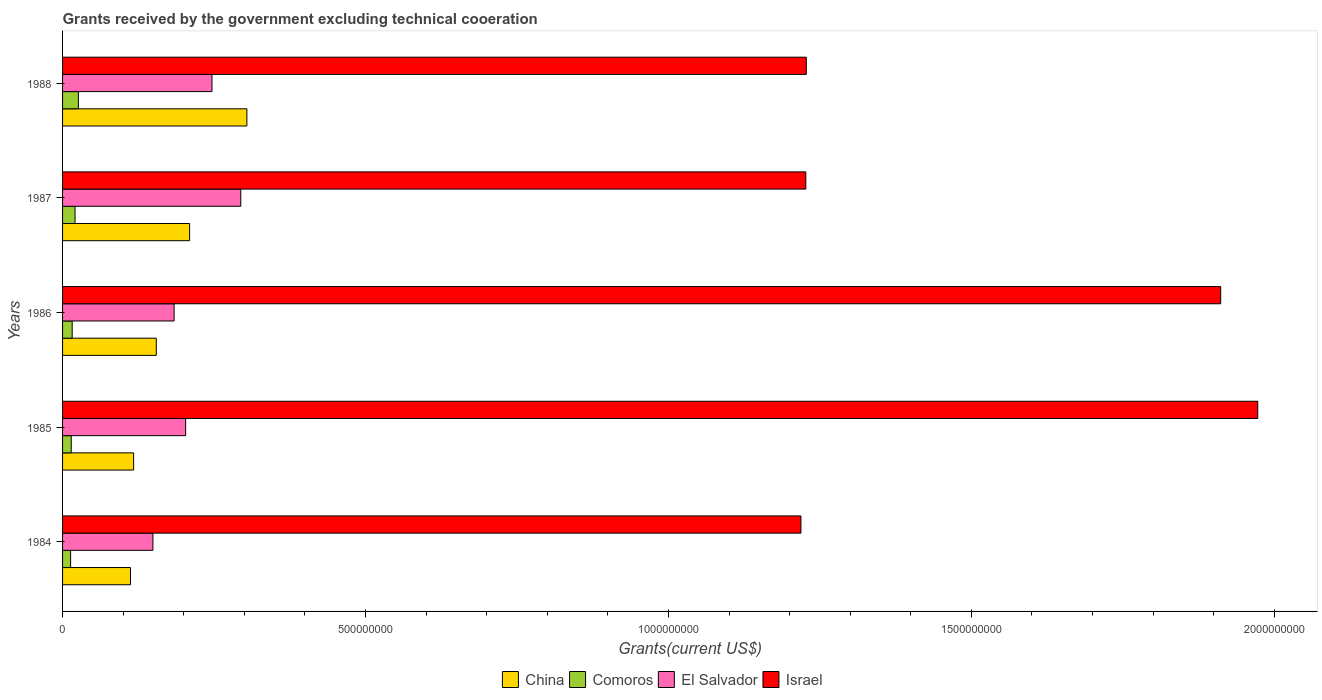How many different coloured bars are there?
Give a very brief answer. 4. Are the number of bars per tick equal to the number of legend labels?
Provide a short and direct response. Yes. How many bars are there on the 3rd tick from the bottom?
Provide a succinct answer. 4. What is the label of the 4th group of bars from the top?
Make the answer very short. 1985. In how many cases, is the number of bars for a given year not equal to the number of legend labels?
Your answer should be very brief. 0. What is the total grants received by the government in Israel in 1984?
Your response must be concise. 1.22e+09. Across all years, what is the maximum total grants received by the government in Israel?
Your answer should be very brief. 1.97e+09. Across all years, what is the minimum total grants received by the government in Israel?
Offer a terse response. 1.22e+09. In which year was the total grants received by the government in China maximum?
Offer a very short reply. 1988. What is the total total grants received by the government in Comoros in the graph?
Offer a very short reply. 9.02e+07. What is the difference between the total grants received by the government in China in 1985 and that in 1987?
Ensure brevity in your answer.  -9.24e+07. What is the difference between the total grants received by the government in Comoros in 1986 and the total grants received by the government in Israel in 1984?
Provide a short and direct response. -1.20e+09. What is the average total grants received by the government in Israel per year?
Your response must be concise. 1.51e+09. In the year 1987, what is the difference between the total grants received by the government in Comoros and total grants received by the government in Israel?
Provide a succinct answer. -1.21e+09. What is the ratio of the total grants received by the government in Comoros in 1984 to that in 1988?
Your answer should be compact. 0.51. Is the total grants received by the government in El Salvador in 1986 less than that in 1987?
Offer a terse response. Yes. What is the difference between the highest and the second highest total grants received by the government in China?
Ensure brevity in your answer.  9.45e+07. What is the difference between the highest and the lowest total grants received by the government in El Salvador?
Your answer should be compact. 1.45e+08. In how many years, is the total grants received by the government in Comoros greater than the average total grants received by the government in Comoros taken over all years?
Your answer should be very brief. 2. Is it the case that in every year, the sum of the total grants received by the government in Comoros and total grants received by the government in El Salvador is greater than the sum of total grants received by the government in China and total grants received by the government in Israel?
Give a very brief answer. No. What does the 2nd bar from the top in 1984 represents?
Make the answer very short. El Salvador. What does the 4th bar from the bottom in 1987 represents?
Provide a short and direct response. Israel. Is it the case that in every year, the sum of the total grants received by the government in El Salvador and total grants received by the government in Israel is greater than the total grants received by the government in China?
Make the answer very short. Yes. How many bars are there?
Provide a succinct answer. 20. Are all the bars in the graph horizontal?
Provide a succinct answer. Yes. What is the difference between two consecutive major ticks on the X-axis?
Offer a very short reply. 5.00e+08. Are the values on the major ticks of X-axis written in scientific E-notation?
Offer a very short reply. No. Does the graph contain any zero values?
Offer a very short reply. No. Where does the legend appear in the graph?
Offer a very short reply. Bottom center. What is the title of the graph?
Make the answer very short. Grants received by the government excluding technical cooeration. What is the label or title of the X-axis?
Your answer should be compact. Grants(current US$). What is the Grants(current US$) in China in 1984?
Ensure brevity in your answer.  1.12e+08. What is the Grants(current US$) in Comoros in 1984?
Keep it short and to the point. 1.33e+07. What is the Grants(current US$) in El Salvador in 1984?
Your answer should be very brief. 1.49e+08. What is the Grants(current US$) in Israel in 1984?
Make the answer very short. 1.22e+09. What is the Grants(current US$) of China in 1985?
Make the answer very short. 1.17e+08. What is the Grants(current US$) of Comoros in 1985?
Ensure brevity in your answer.  1.43e+07. What is the Grants(current US$) in El Salvador in 1985?
Make the answer very short. 2.03e+08. What is the Grants(current US$) in Israel in 1985?
Your answer should be compact. 1.97e+09. What is the Grants(current US$) of China in 1986?
Offer a terse response. 1.55e+08. What is the Grants(current US$) of Comoros in 1986?
Offer a very short reply. 1.59e+07. What is the Grants(current US$) in El Salvador in 1986?
Offer a very short reply. 1.84e+08. What is the Grants(current US$) in Israel in 1986?
Your answer should be very brief. 1.91e+09. What is the Grants(current US$) in China in 1987?
Ensure brevity in your answer.  2.10e+08. What is the Grants(current US$) in Comoros in 1987?
Ensure brevity in your answer.  2.06e+07. What is the Grants(current US$) in El Salvador in 1987?
Provide a short and direct response. 2.94e+08. What is the Grants(current US$) in Israel in 1987?
Offer a terse response. 1.23e+09. What is the Grants(current US$) of China in 1988?
Your answer should be very brief. 3.04e+08. What is the Grants(current US$) of Comoros in 1988?
Your response must be concise. 2.61e+07. What is the Grants(current US$) in El Salvador in 1988?
Give a very brief answer. 2.47e+08. What is the Grants(current US$) in Israel in 1988?
Ensure brevity in your answer.  1.23e+09. Across all years, what is the maximum Grants(current US$) in China?
Make the answer very short. 3.04e+08. Across all years, what is the maximum Grants(current US$) of Comoros?
Ensure brevity in your answer.  2.61e+07. Across all years, what is the maximum Grants(current US$) of El Salvador?
Your answer should be very brief. 2.94e+08. Across all years, what is the maximum Grants(current US$) of Israel?
Make the answer very short. 1.97e+09. Across all years, what is the minimum Grants(current US$) in China?
Your answer should be compact. 1.12e+08. Across all years, what is the minimum Grants(current US$) of Comoros?
Ensure brevity in your answer.  1.33e+07. Across all years, what is the minimum Grants(current US$) in El Salvador?
Offer a terse response. 1.49e+08. Across all years, what is the minimum Grants(current US$) of Israel?
Keep it short and to the point. 1.22e+09. What is the total Grants(current US$) of China in the graph?
Give a very brief answer. 8.98e+08. What is the total Grants(current US$) of Comoros in the graph?
Ensure brevity in your answer.  9.02e+07. What is the total Grants(current US$) in El Salvador in the graph?
Make the answer very short. 1.08e+09. What is the total Grants(current US$) of Israel in the graph?
Your answer should be very brief. 7.56e+09. What is the difference between the Grants(current US$) in China in 1984 and that in 1985?
Offer a very short reply. -5.24e+06. What is the difference between the Grants(current US$) of Comoros in 1984 and that in 1985?
Your answer should be compact. -1.02e+06. What is the difference between the Grants(current US$) in El Salvador in 1984 and that in 1985?
Ensure brevity in your answer.  -5.40e+07. What is the difference between the Grants(current US$) of Israel in 1984 and that in 1985?
Provide a succinct answer. -7.54e+08. What is the difference between the Grants(current US$) of China in 1984 and that in 1986?
Keep it short and to the point. -4.26e+07. What is the difference between the Grants(current US$) in Comoros in 1984 and that in 1986?
Keep it short and to the point. -2.57e+06. What is the difference between the Grants(current US$) in El Salvador in 1984 and that in 1986?
Ensure brevity in your answer.  -3.50e+07. What is the difference between the Grants(current US$) in Israel in 1984 and that in 1986?
Make the answer very short. -6.93e+08. What is the difference between the Grants(current US$) in China in 1984 and that in 1987?
Ensure brevity in your answer.  -9.76e+07. What is the difference between the Grants(current US$) of Comoros in 1984 and that in 1987?
Offer a terse response. -7.29e+06. What is the difference between the Grants(current US$) in El Salvador in 1984 and that in 1987?
Offer a terse response. -1.45e+08. What is the difference between the Grants(current US$) in Israel in 1984 and that in 1987?
Provide a short and direct response. -8.04e+06. What is the difference between the Grants(current US$) in China in 1984 and that in 1988?
Keep it short and to the point. -1.92e+08. What is the difference between the Grants(current US$) in Comoros in 1984 and that in 1988?
Offer a very short reply. -1.28e+07. What is the difference between the Grants(current US$) in El Salvador in 1984 and that in 1988?
Your answer should be very brief. -9.75e+07. What is the difference between the Grants(current US$) of Israel in 1984 and that in 1988?
Provide a short and direct response. -8.83e+06. What is the difference between the Grants(current US$) of China in 1985 and that in 1986?
Make the answer very short. -3.74e+07. What is the difference between the Grants(current US$) in Comoros in 1985 and that in 1986?
Provide a short and direct response. -1.55e+06. What is the difference between the Grants(current US$) in El Salvador in 1985 and that in 1986?
Keep it short and to the point. 1.90e+07. What is the difference between the Grants(current US$) in Israel in 1985 and that in 1986?
Ensure brevity in your answer.  6.12e+07. What is the difference between the Grants(current US$) of China in 1985 and that in 1987?
Ensure brevity in your answer.  -9.24e+07. What is the difference between the Grants(current US$) of Comoros in 1985 and that in 1987?
Provide a short and direct response. -6.27e+06. What is the difference between the Grants(current US$) of El Salvador in 1985 and that in 1987?
Offer a very short reply. -9.10e+07. What is the difference between the Grants(current US$) of Israel in 1985 and that in 1987?
Offer a terse response. 7.46e+08. What is the difference between the Grants(current US$) of China in 1985 and that in 1988?
Your response must be concise. -1.87e+08. What is the difference between the Grants(current US$) of Comoros in 1985 and that in 1988?
Your answer should be very brief. -1.18e+07. What is the difference between the Grants(current US$) in El Salvador in 1985 and that in 1988?
Give a very brief answer. -4.35e+07. What is the difference between the Grants(current US$) in Israel in 1985 and that in 1988?
Keep it short and to the point. 7.45e+08. What is the difference between the Grants(current US$) of China in 1986 and that in 1987?
Your answer should be very brief. -5.50e+07. What is the difference between the Grants(current US$) in Comoros in 1986 and that in 1987?
Ensure brevity in your answer.  -4.72e+06. What is the difference between the Grants(current US$) of El Salvador in 1986 and that in 1987?
Keep it short and to the point. -1.10e+08. What is the difference between the Grants(current US$) in Israel in 1986 and that in 1987?
Give a very brief answer. 6.85e+08. What is the difference between the Grants(current US$) in China in 1986 and that in 1988?
Keep it short and to the point. -1.49e+08. What is the difference between the Grants(current US$) in Comoros in 1986 and that in 1988?
Your answer should be compact. -1.03e+07. What is the difference between the Grants(current US$) of El Salvador in 1986 and that in 1988?
Ensure brevity in your answer.  -6.25e+07. What is the difference between the Grants(current US$) in Israel in 1986 and that in 1988?
Keep it short and to the point. 6.84e+08. What is the difference between the Grants(current US$) in China in 1987 and that in 1988?
Your answer should be compact. -9.45e+07. What is the difference between the Grants(current US$) in Comoros in 1987 and that in 1988?
Offer a terse response. -5.54e+06. What is the difference between the Grants(current US$) in El Salvador in 1987 and that in 1988?
Offer a terse response. 4.76e+07. What is the difference between the Grants(current US$) of Israel in 1987 and that in 1988?
Ensure brevity in your answer.  -7.90e+05. What is the difference between the Grants(current US$) in China in 1984 and the Grants(current US$) in Comoros in 1985?
Keep it short and to the point. 9.78e+07. What is the difference between the Grants(current US$) in China in 1984 and the Grants(current US$) in El Salvador in 1985?
Offer a very short reply. -9.11e+07. What is the difference between the Grants(current US$) of China in 1984 and the Grants(current US$) of Israel in 1985?
Your answer should be very brief. -1.86e+09. What is the difference between the Grants(current US$) in Comoros in 1984 and the Grants(current US$) in El Salvador in 1985?
Your response must be concise. -1.90e+08. What is the difference between the Grants(current US$) in Comoros in 1984 and the Grants(current US$) in Israel in 1985?
Offer a terse response. -1.96e+09. What is the difference between the Grants(current US$) of El Salvador in 1984 and the Grants(current US$) of Israel in 1985?
Your response must be concise. -1.82e+09. What is the difference between the Grants(current US$) in China in 1984 and the Grants(current US$) in Comoros in 1986?
Offer a terse response. 9.62e+07. What is the difference between the Grants(current US$) in China in 1984 and the Grants(current US$) in El Salvador in 1986?
Your answer should be compact. -7.21e+07. What is the difference between the Grants(current US$) of China in 1984 and the Grants(current US$) of Israel in 1986?
Offer a terse response. -1.80e+09. What is the difference between the Grants(current US$) in Comoros in 1984 and the Grants(current US$) in El Salvador in 1986?
Give a very brief answer. -1.71e+08. What is the difference between the Grants(current US$) of Comoros in 1984 and the Grants(current US$) of Israel in 1986?
Provide a short and direct response. -1.90e+09. What is the difference between the Grants(current US$) in El Salvador in 1984 and the Grants(current US$) in Israel in 1986?
Offer a very short reply. -1.76e+09. What is the difference between the Grants(current US$) in China in 1984 and the Grants(current US$) in Comoros in 1987?
Offer a terse response. 9.15e+07. What is the difference between the Grants(current US$) in China in 1984 and the Grants(current US$) in El Salvador in 1987?
Give a very brief answer. -1.82e+08. What is the difference between the Grants(current US$) of China in 1984 and the Grants(current US$) of Israel in 1987?
Your answer should be very brief. -1.11e+09. What is the difference between the Grants(current US$) in Comoros in 1984 and the Grants(current US$) in El Salvador in 1987?
Your answer should be very brief. -2.81e+08. What is the difference between the Grants(current US$) in Comoros in 1984 and the Grants(current US$) in Israel in 1987?
Provide a short and direct response. -1.21e+09. What is the difference between the Grants(current US$) in El Salvador in 1984 and the Grants(current US$) in Israel in 1987?
Give a very brief answer. -1.08e+09. What is the difference between the Grants(current US$) of China in 1984 and the Grants(current US$) of Comoros in 1988?
Your answer should be compact. 8.60e+07. What is the difference between the Grants(current US$) in China in 1984 and the Grants(current US$) in El Salvador in 1988?
Provide a succinct answer. -1.35e+08. What is the difference between the Grants(current US$) in China in 1984 and the Grants(current US$) in Israel in 1988?
Provide a succinct answer. -1.12e+09. What is the difference between the Grants(current US$) of Comoros in 1984 and the Grants(current US$) of El Salvador in 1988?
Your response must be concise. -2.33e+08. What is the difference between the Grants(current US$) of Comoros in 1984 and the Grants(current US$) of Israel in 1988?
Give a very brief answer. -1.21e+09. What is the difference between the Grants(current US$) of El Salvador in 1984 and the Grants(current US$) of Israel in 1988?
Make the answer very short. -1.08e+09. What is the difference between the Grants(current US$) in China in 1985 and the Grants(current US$) in Comoros in 1986?
Make the answer very short. 1.01e+08. What is the difference between the Grants(current US$) of China in 1985 and the Grants(current US$) of El Salvador in 1986?
Give a very brief answer. -6.68e+07. What is the difference between the Grants(current US$) of China in 1985 and the Grants(current US$) of Israel in 1986?
Offer a very short reply. -1.79e+09. What is the difference between the Grants(current US$) of Comoros in 1985 and the Grants(current US$) of El Salvador in 1986?
Ensure brevity in your answer.  -1.70e+08. What is the difference between the Grants(current US$) in Comoros in 1985 and the Grants(current US$) in Israel in 1986?
Offer a terse response. -1.90e+09. What is the difference between the Grants(current US$) of El Salvador in 1985 and the Grants(current US$) of Israel in 1986?
Your response must be concise. -1.71e+09. What is the difference between the Grants(current US$) in China in 1985 and the Grants(current US$) in Comoros in 1987?
Ensure brevity in your answer.  9.67e+07. What is the difference between the Grants(current US$) of China in 1985 and the Grants(current US$) of El Salvador in 1987?
Provide a short and direct response. -1.77e+08. What is the difference between the Grants(current US$) of China in 1985 and the Grants(current US$) of Israel in 1987?
Your answer should be compact. -1.11e+09. What is the difference between the Grants(current US$) of Comoros in 1985 and the Grants(current US$) of El Salvador in 1987?
Your answer should be compact. -2.80e+08. What is the difference between the Grants(current US$) in Comoros in 1985 and the Grants(current US$) in Israel in 1987?
Give a very brief answer. -1.21e+09. What is the difference between the Grants(current US$) in El Salvador in 1985 and the Grants(current US$) in Israel in 1987?
Provide a short and direct response. -1.02e+09. What is the difference between the Grants(current US$) of China in 1985 and the Grants(current US$) of Comoros in 1988?
Offer a terse response. 9.12e+07. What is the difference between the Grants(current US$) in China in 1985 and the Grants(current US$) in El Salvador in 1988?
Provide a succinct answer. -1.29e+08. What is the difference between the Grants(current US$) of China in 1985 and the Grants(current US$) of Israel in 1988?
Your answer should be compact. -1.11e+09. What is the difference between the Grants(current US$) in Comoros in 1985 and the Grants(current US$) in El Salvador in 1988?
Provide a succinct answer. -2.32e+08. What is the difference between the Grants(current US$) in Comoros in 1985 and the Grants(current US$) in Israel in 1988?
Keep it short and to the point. -1.21e+09. What is the difference between the Grants(current US$) in El Salvador in 1985 and the Grants(current US$) in Israel in 1988?
Give a very brief answer. -1.02e+09. What is the difference between the Grants(current US$) in China in 1986 and the Grants(current US$) in Comoros in 1987?
Provide a short and direct response. 1.34e+08. What is the difference between the Grants(current US$) in China in 1986 and the Grants(current US$) in El Salvador in 1987?
Offer a very short reply. -1.39e+08. What is the difference between the Grants(current US$) in China in 1986 and the Grants(current US$) in Israel in 1987?
Offer a very short reply. -1.07e+09. What is the difference between the Grants(current US$) in Comoros in 1986 and the Grants(current US$) in El Salvador in 1987?
Your response must be concise. -2.78e+08. What is the difference between the Grants(current US$) of Comoros in 1986 and the Grants(current US$) of Israel in 1987?
Your answer should be compact. -1.21e+09. What is the difference between the Grants(current US$) of El Salvador in 1986 and the Grants(current US$) of Israel in 1987?
Your answer should be compact. -1.04e+09. What is the difference between the Grants(current US$) in China in 1986 and the Grants(current US$) in Comoros in 1988?
Your answer should be very brief. 1.29e+08. What is the difference between the Grants(current US$) of China in 1986 and the Grants(current US$) of El Salvador in 1988?
Your answer should be very brief. -9.19e+07. What is the difference between the Grants(current US$) of China in 1986 and the Grants(current US$) of Israel in 1988?
Keep it short and to the point. -1.07e+09. What is the difference between the Grants(current US$) in Comoros in 1986 and the Grants(current US$) in El Salvador in 1988?
Make the answer very short. -2.31e+08. What is the difference between the Grants(current US$) in Comoros in 1986 and the Grants(current US$) in Israel in 1988?
Make the answer very short. -1.21e+09. What is the difference between the Grants(current US$) in El Salvador in 1986 and the Grants(current US$) in Israel in 1988?
Your answer should be very brief. -1.04e+09. What is the difference between the Grants(current US$) of China in 1987 and the Grants(current US$) of Comoros in 1988?
Offer a terse response. 1.84e+08. What is the difference between the Grants(current US$) of China in 1987 and the Grants(current US$) of El Salvador in 1988?
Your answer should be compact. -3.69e+07. What is the difference between the Grants(current US$) of China in 1987 and the Grants(current US$) of Israel in 1988?
Keep it short and to the point. -1.02e+09. What is the difference between the Grants(current US$) in Comoros in 1987 and the Grants(current US$) in El Salvador in 1988?
Keep it short and to the point. -2.26e+08. What is the difference between the Grants(current US$) of Comoros in 1987 and the Grants(current US$) of Israel in 1988?
Offer a very short reply. -1.21e+09. What is the difference between the Grants(current US$) in El Salvador in 1987 and the Grants(current US$) in Israel in 1988?
Ensure brevity in your answer.  -9.33e+08. What is the average Grants(current US$) in China per year?
Keep it short and to the point. 1.80e+08. What is the average Grants(current US$) in Comoros per year?
Provide a succinct answer. 1.80e+07. What is the average Grants(current US$) of El Salvador per year?
Provide a short and direct response. 2.15e+08. What is the average Grants(current US$) of Israel per year?
Give a very brief answer. 1.51e+09. In the year 1984, what is the difference between the Grants(current US$) of China and Grants(current US$) of Comoros?
Your answer should be compact. 9.88e+07. In the year 1984, what is the difference between the Grants(current US$) in China and Grants(current US$) in El Salvador?
Your answer should be very brief. -3.71e+07. In the year 1984, what is the difference between the Grants(current US$) in China and Grants(current US$) in Israel?
Provide a short and direct response. -1.11e+09. In the year 1984, what is the difference between the Grants(current US$) in Comoros and Grants(current US$) in El Salvador?
Your response must be concise. -1.36e+08. In the year 1984, what is the difference between the Grants(current US$) in Comoros and Grants(current US$) in Israel?
Offer a terse response. -1.21e+09. In the year 1984, what is the difference between the Grants(current US$) in El Salvador and Grants(current US$) in Israel?
Provide a short and direct response. -1.07e+09. In the year 1985, what is the difference between the Grants(current US$) of China and Grants(current US$) of Comoros?
Provide a short and direct response. 1.03e+08. In the year 1985, what is the difference between the Grants(current US$) of China and Grants(current US$) of El Salvador?
Offer a very short reply. -8.58e+07. In the year 1985, what is the difference between the Grants(current US$) of China and Grants(current US$) of Israel?
Keep it short and to the point. -1.86e+09. In the year 1985, what is the difference between the Grants(current US$) of Comoros and Grants(current US$) of El Salvador?
Offer a very short reply. -1.89e+08. In the year 1985, what is the difference between the Grants(current US$) of Comoros and Grants(current US$) of Israel?
Ensure brevity in your answer.  -1.96e+09. In the year 1985, what is the difference between the Grants(current US$) of El Salvador and Grants(current US$) of Israel?
Give a very brief answer. -1.77e+09. In the year 1986, what is the difference between the Grants(current US$) of China and Grants(current US$) of Comoros?
Your answer should be very brief. 1.39e+08. In the year 1986, what is the difference between the Grants(current US$) in China and Grants(current US$) in El Salvador?
Provide a succinct answer. -2.94e+07. In the year 1986, what is the difference between the Grants(current US$) in China and Grants(current US$) in Israel?
Offer a terse response. -1.76e+09. In the year 1986, what is the difference between the Grants(current US$) in Comoros and Grants(current US$) in El Salvador?
Your answer should be compact. -1.68e+08. In the year 1986, what is the difference between the Grants(current US$) of Comoros and Grants(current US$) of Israel?
Offer a very short reply. -1.90e+09. In the year 1986, what is the difference between the Grants(current US$) in El Salvador and Grants(current US$) in Israel?
Your response must be concise. -1.73e+09. In the year 1987, what is the difference between the Grants(current US$) in China and Grants(current US$) in Comoros?
Your answer should be compact. 1.89e+08. In the year 1987, what is the difference between the Grants(current US$) of China and Grants(current US$) of El Salvador?
Keep it short and to the point. -8.45e+07. In the year 1987, what is the difference between the Grants(current US$) of China and Grants(current US$) of Israel?
Give a very brief answer. -1.02e+09. In the year 1987, what is the difference between the Grants(current US$) of Comoros and Grants(current US$) of El Salvador?
Your response must be concise. -2.74e+08. In the year 1987, what is the difference between the Grants(current US$) in Comoros and Grants(current US$) in Israel?
Your response must be concise. -1.21e+09. In the year 1987, what is the difference between the Grants(current US$) of El Salvador and Grants(current US$) of Israel?
Ensure brevity in your answer.  -9.33e+08. In the year 1988, what is the difference between the Grants(current US$) in China and Grants(current US$) in Comoros?
Your answer should be compact. 2.78e+08. In the year 1988, what is the difference between the Grants(current US$) in China and Grants(current US$) in El Salvador?
Keep it short and to the point. 5.76e+07. In the year 1988, what is the difference between the Grants(current US$) of China and Grants(current US$) of Israel?
Give a very brief answer. -9.23e+08. In the year 1988, what is the difference between the Grants(current US$) in Comoros and Grants(current US$) in El Salvador?
Provide a succinct answer. -2.20e+08. In the year 1988, what is the difference between the Grants(current US$) in Comoros and Grants(current US$) in Israel?
Provide a succinct answer. -1.20e+09. In the year 1988, what is the difference between the Grants(current US$) of El Salvador and Grants(current US$) of Israel?
Make the answer very short. -9.81e+08. What is the ratio of the Grants(current US$) of China in 1984 to that in 1985?
Give a very brief answer. 0.96. What is the ratio of the Grants(current US$) of Comoros in 1984 to that in 1985?
Provide a succinct answer. 0.93. What is the ratio of the Grants(current US$) of El Salvador in 1984 to that in 1985?
Offer a very short reply. 0.73. What is the ratio of the Grants(current US$) of Israel in 1984 to that in 1985?
Provide a succinct answer. 0.62. What is the ratio of the Grants(current US$) in China in 1984 to that in 1986?
Keep it short and to the point. 0.72. What is the ratio of the Grants(current US$) in Comoros in 1984 to that in 1986?
Offer a terse response. 0.84. What is the ratio of the Grants(current US$) in El Salvador in 1984 to that in 1986?
Provide a short and direct response. 0.81. What is the ratio of the Grants(current US$) of Israel in 1984 to that in 1986?
Keep it short and to the point. 0.64. What is the ratio of the Grants(current US$) in China in 1984 to that in 1987?
Make the answer very short. 0.53. What is the ratio of the Grants(current US$) in Comoros in 1984 to that in 1987?
Give a very brief answer. 0.65. What is the ratio of the Grants(current US$) in El Salvador in 1984 to that in 1987?
Your answer should be very brief. 0.51. What is the ratio of the Grants(current US$) of China in 1984 to that in 1988?
Your response must be concise. 0.37. What is the ratio of the Grants(current US$) in Comoros in 1984 to that in 1988?
Provide a short and direct response. 0.51. What is the ratio of the Grants(current US$) in El Salvador in 1984 to that in 1988?
Offer a terse response. 0.6. What is the ratio of the Grants(current US$) of Israel in 1984 to that in 1988?
Offer a very short reply. 0.99. What is the ratio of the Grants(current US$) in China in 1985 to that in 1986?
Offer a very short reply. 0.76. What is the ratio of the Grants(current US$) in Comoros in 1985 to that in 1986?
Give a very brief answer. 0.9. What is the ratio of the Grants(current US$) of El Salvador in 1985 to that in 1986?
Keep it short and to the point. 1.1. What is the ratio of the Grants(current US$) of Israel in 1985 to that in 1986?
Provide a short and direct response. 1.03. What is the ratio of the Grants(current US$) of China in 1985 to that in 1987?
Give a very brief answer. 0.56. What is the ratio of the Grants(current US$) in Comoros in 1985 to that in 1987?
Make the answer very short. 0.7. What is the ratio of the Grants(current US$) in El Salvador in 1985 to that in 1987?
Your answer should be very brief. 0.69. What is the ratio of the Grants(current US$) of Israel in 1985 to that in 1987?
Your answer should be very brief. 1.61. What is the ratio of the Grants(current US$) in China in 1985 to that in 1988?
Your answer should be compact. 0.39. What is the ratio of the Grants(current US$) in Comoros in 1985 to that in 1988?
Ensure brevity in your answer.  0.55. What is the ratio of the Grants(current US$) of El Salvador in 1985 to that in 1988?
Make the answer very short. 0.82. What is the ratio of the Grants(current US$) of Israel in 1985 to that in 1988?
Offer a terse response. 1.61. What is the ratio of the Grants(current US$) in China in 1986 to that in 1987?
Offer a very short reply. 0.74. What is the ratio of the Grants(current US$) in Comoros in 1986 to that in 1987?
Your answer should be compact. 0.77. What is the ratio of the Grants(current US$) of El Salvador in 1986 to that in 1987?
Keep it short and to the point. 0.63. What is the ratio of the Grants(current US$) of Israel in 1986 to that in 1987?
Your response must be concise. 1.56. What is the ratio of the Grants(current US$) in China in 1986 to that in 1988?
Make the answer very short. 0.51. What is the ratio of the Grants(current US$) in Comoros in 1986 to that in 1988?
Provide a short and direct response. 0.61. What is the ratio of the Grants(current US$) of El Salvador in 1986 to that in 1988?
Offer a terse response. 0.75. What is the ratio of the Grants(current US$) of Israel in 1986 to that in 1988?
Make the answer very short. 1.56. What is the ratio of the Grants(current US$) of China in 1987 to that in 1988?
Offer a terse response. 0.69. What is the ratio of the Grants(current US$) in Comoros in 1987 to that in 1988?
Provide a succinct answer. 0.79. What is the ratio of the Grants(current US$) of El Salvador in 1987 to that in 1988?
Keep it short and to the point. 1.19. What is the difference between the highest and the second highest Grants(current US$) of China?
Your response must be concise. 9.45e+07. What is the difference between the highest and the second highest Grants(current US$) in Comoros?
Offer a terse response. 5.54e+06. What is the difference between the highest and the second highest Grants(current US$) in El Salvador?
Your response must be concise. 4.76e+07. What is the difference between the highest and the second highest Grants(current US$) in Israel?
Your response must be concise. 6.12e+07. What is the difference between the highest and the lowest Grants(current US$) in China?
Give a very brief answer. 1.92e+08. What is the difference between the highest and the lowest Grants(current US$) in Comoros?
Provide a short and direct response. 1.28e+07. What is the difference between the highest and the lowest Grants(current US$) of El Salvador?
Your answer should be compact. 1.45e+08. What is the difference between the highest and the lowest Grants(current US$) of Israel?
Keep it short and to the point. 7.54e+08. 